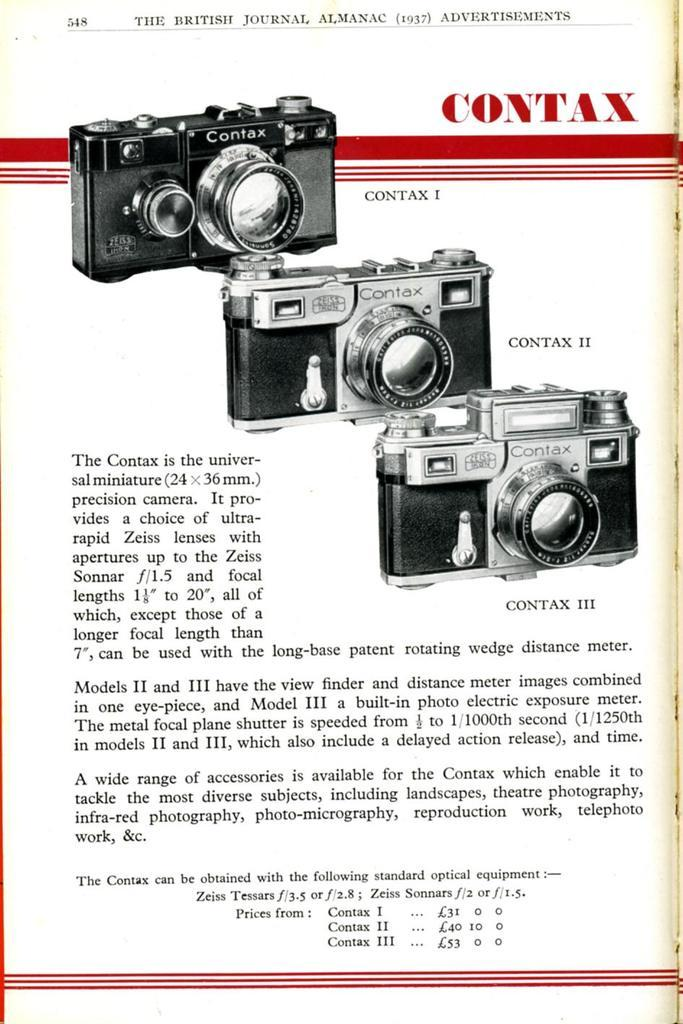<image>
Create a compact narrative representing the image presented. A picture of a camera and how to use it 